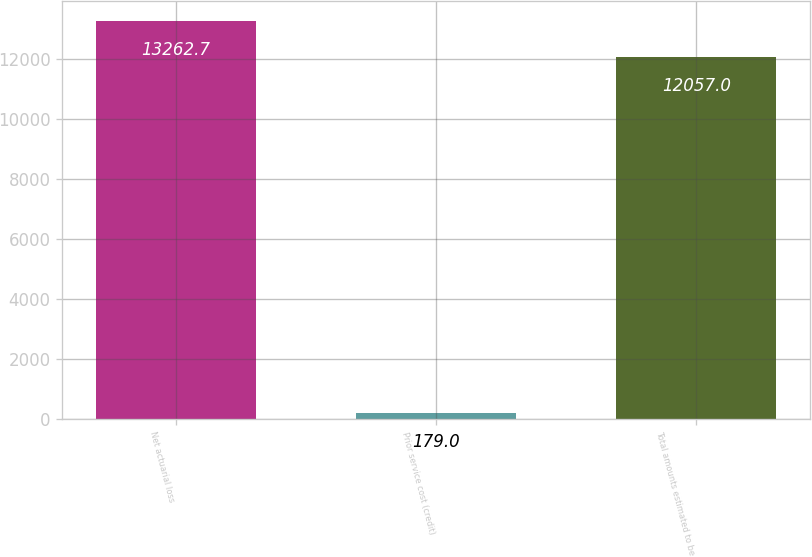<chart> <loc_0><loc_0><loc_500><loc_500><bar_chart><fcel>Net actuarial loss<fcel>Prior service cost (credit)<fcel>Total amounts estimated to be<nl><fcel>13262.7<fcel>179<fcel>12057<nl></chart> 